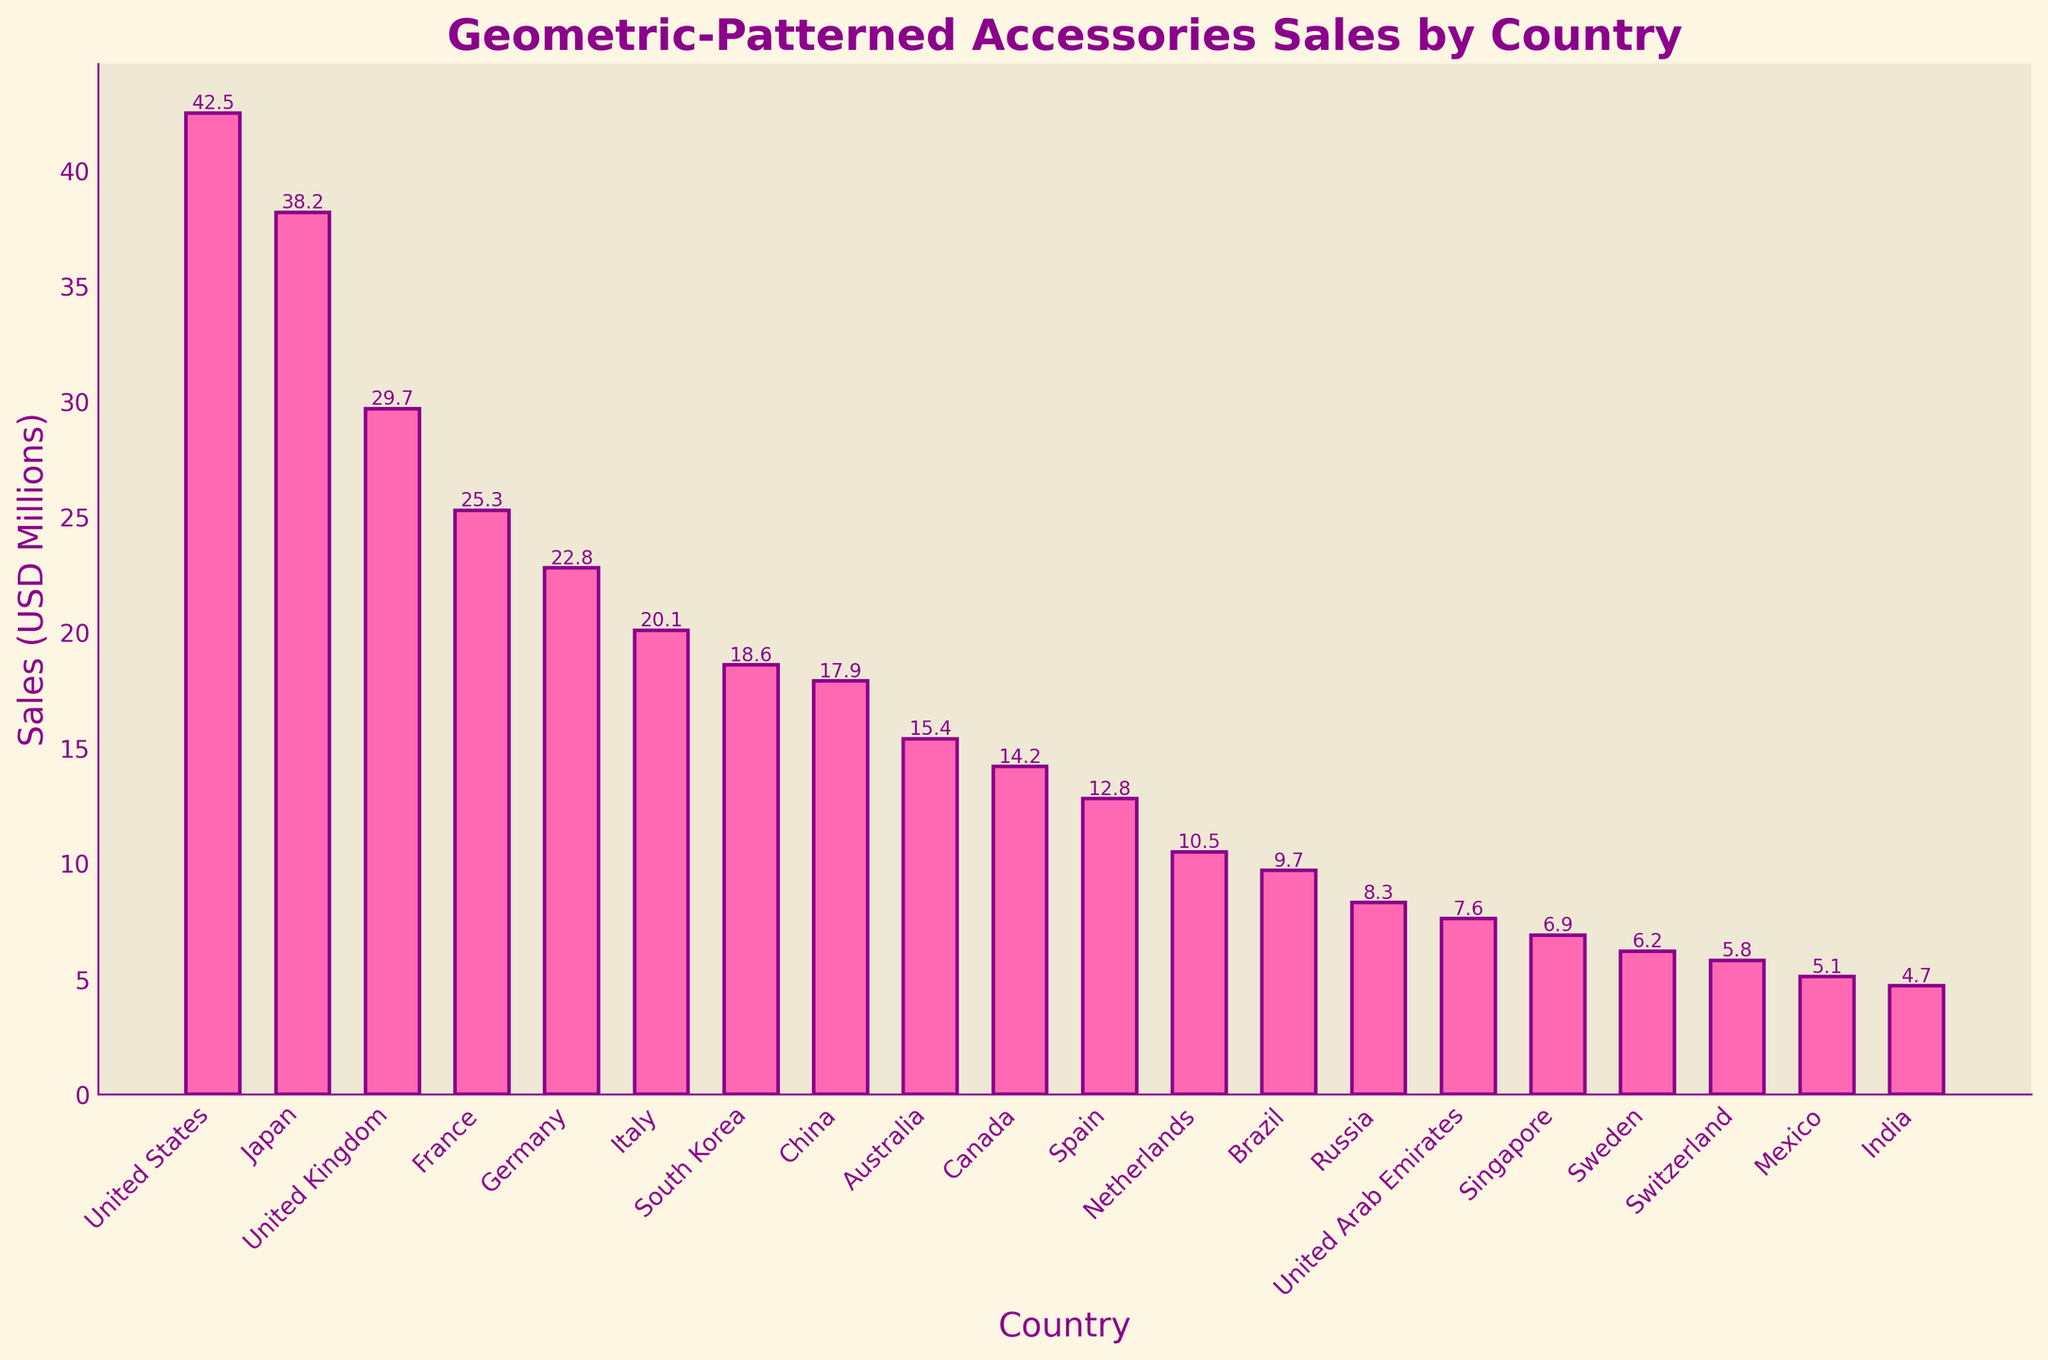Which country has the highest sales for geometric-patterned accessories? Look at the heights of the bars and identify the tallest one. The United States has the highest bar.
Answer: United States What is the total sales figure for the top three countries combined? Identify the sales figures for the top three countries: United States (42.5), Japan (38.2), and United Kingdom (29.7). Sum them: 42.5 + 38.2 + 29.7 = 110.4.
Answer: 110.4 Which countries have sales figures below 10 million USD? Look for bars with heights representing values below 10 million USD. The countries are Brazil (9.7), Russia (8.3), United Arab Emirates (7.6), Singapore (6.9), Sweden (6.2), Switzerland (5.8), Mexico (5.1), and India (4.7).
Answer: Brazil, Russia, United Arab Emirates, Singapore, Sweden, Switzerland, Mexico, India What is the difference in sales between Germany and France? Identify the sales figures for Germany (22.8) and France (25.3). Subtract Germany's sales from France's sales: 25.3 - 22.8 = 2.5.
Answer: 2.5 Which country is ranked fifth in terms of sales? Identify and sort the sales figures. The fifth highest sales figure is for Germany (22.8).
Answer: Germany What's the average sales figure for the bottom five countries? Identify the sales figures for the bottom five countries: United Arab Emirates (7.6), Singapore (6.9), Sweden (6.2), Switzerland (5.8), and Mexico (5.1). Sum them: 7.6 + 6.9 + 6.2 + 5.8 + 5.1 = 31.6. Then, divide by 5: 31.6 / 5 = 6.32.
Answer: 6.32 Between South Korea and Australia, which country has higher sales and by how much? Identify the sales figures for South Korea (18.6) and Australia (15.4). Subtract Australia's sales from South Korea's sales: 18.6 - 15.4 = 3.2.
Answer: South Korea, 3.2 How many countries have sales figures greater than 20 million USD? Identify the sales figures above 20 million USD. The countries are United States (42.5), Japan (38.2), United Kingdom (29.7), France (25.3), Germany (22.8), and Italy (20.1).
Answer: 6 What is the combined sales figure for all European countries shown in the chart? Identify the European countries and their sales figures: United Kingdom (29.7), France (25.3), Germany (22.8), Italy (20.1), Spain (12.8), Netherlands (10.5), Sweden (6.2), and Switzerland (5.8). Sum them: 29.7 + 25.3 + 22.8 + 20.1 + 12.8 + 10.5 + 6.2 + 5.8 = 133.2.
Answer: 133.2 Which country has the lowest sales figure, and what is its value? Look for the shortest bar which represents the lowest sales figure. India has the lowest sales figure at 4.7 million USD.
Answer: India, 4.7 